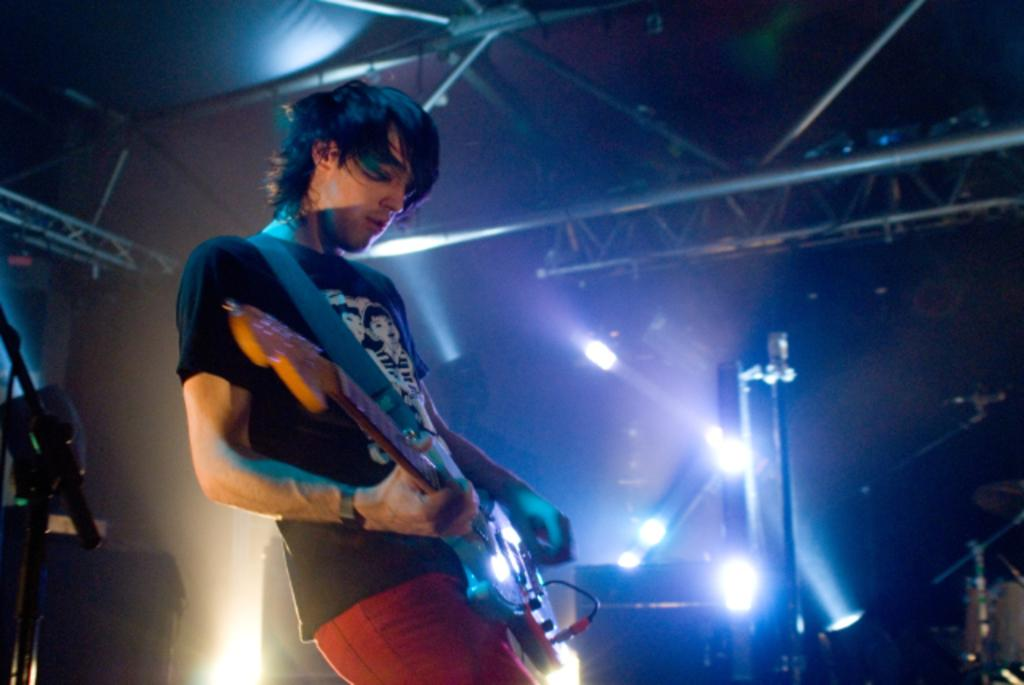Who is the person in the image? There is a man in the image. What is the man doing in the image? The man is playing a guitar. What can be seen in the image that might be used for lighting? There are focusing lights visible in the image. What type of bread is the man using to rub the guitar strings in the image? There is no bread present in the image, and the man is not rubbing the guitar strings with any object. 